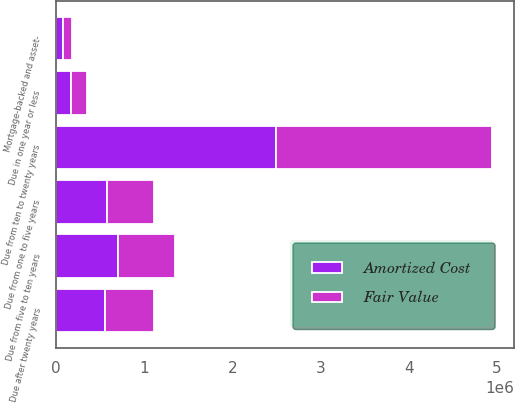<chart> <loc_0><loc_0><loc_500><loc_500><stacked_bar_chart><ecel><fcel>Due in one year or less<fcel>Due from one to five years<fcel>Due from five to ten years<fcel>Due from ten to twenty years<fcel>Due after twenty years<fcel>Mortgage-backed and asset-<nl><fcel>Fair Value<fcel>173468<fcel>537064<fcel>652335<fcel>2.45442e+06<fcel>556770<fcel>109523<nl><fcel>Amortized Cost<fcel>175980<fcel>576475<fcel>698910<fcel>2.49082e+06<fcel>556770<fcel>78761<nl></chart> 